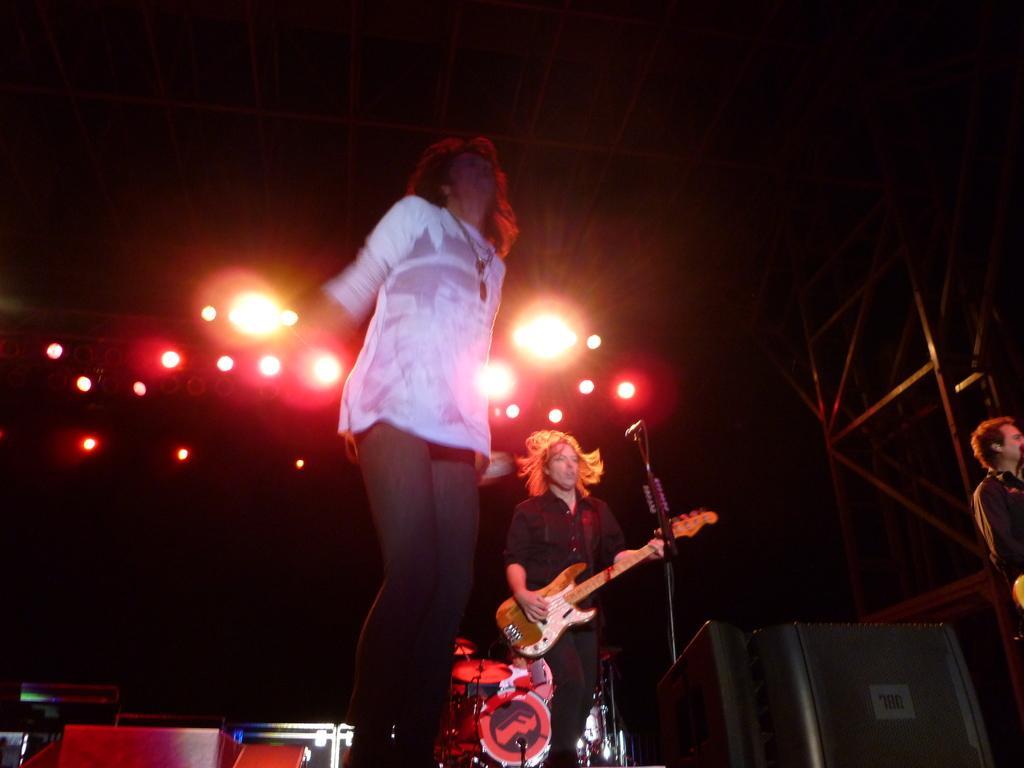Can you describe this image briefly? The women wearing white dress is standing and the persons wearing black dress is playing guitar in front of the mic and the person wearing white dress is playing drums and there are lighting on the top. 